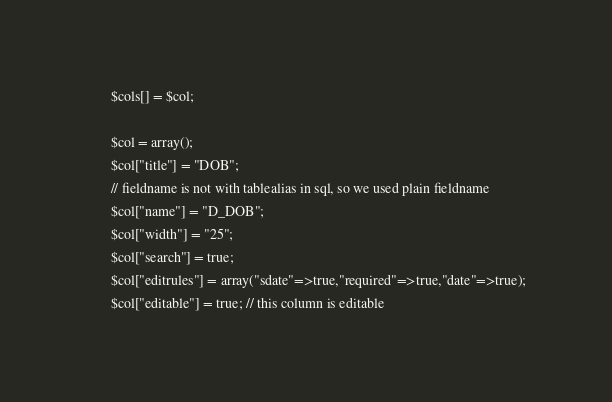Convert code to text. <code><loc_0><loc_0><loc_500><loc_500><_PHP_>	   $cols[] = $col;

	   $col = array();
	   $col["title"] = "DOB";
	   // fieldname is not with tablealias in sql, so we used plain fieldname
	   $col["name"] = "D_DOB"; 
	   $col["width"] = "25";
	   $col["search"] = true;
	   $col["editrules"] = array("sdate"=>true,"required"=>true,"date"=>true);
	   $col["editable"] = true; // this column is editable</code> 